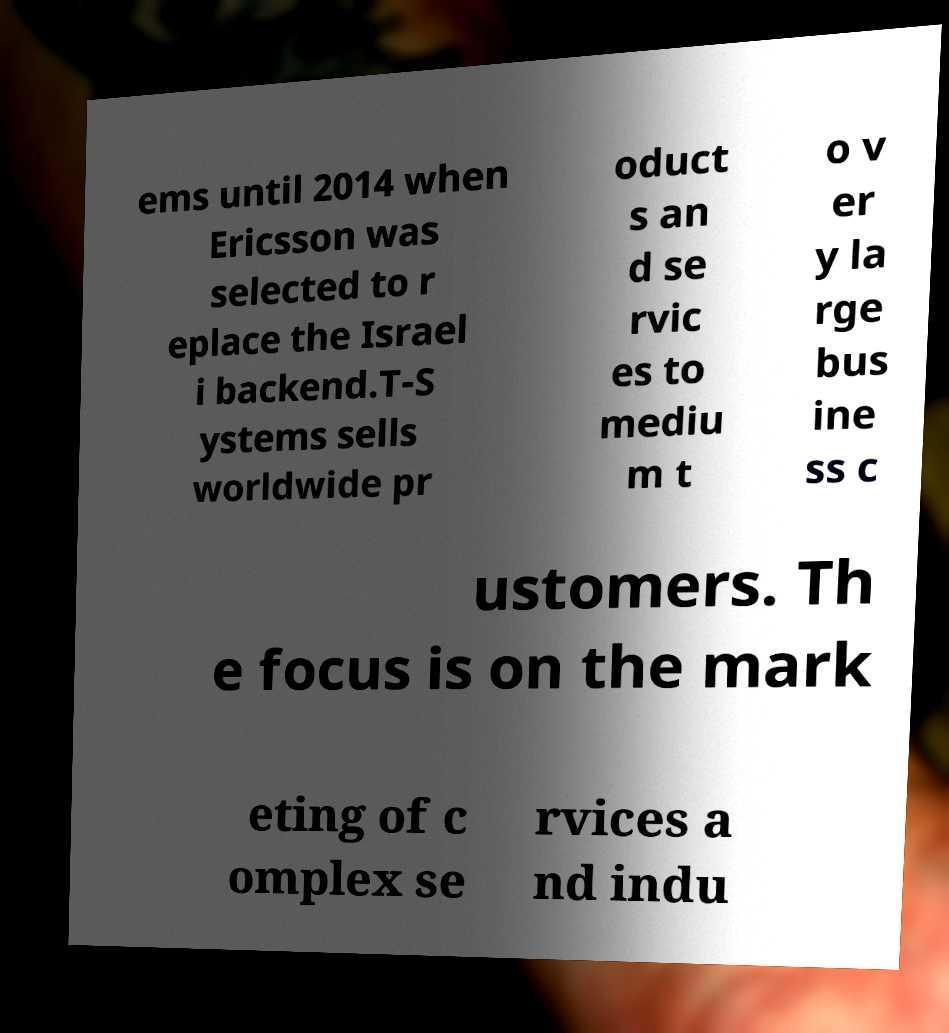Can you read and provide the text displayed in the image?This photo seems to have some interesting text. Can you extract and type it out for me? ems until 2014 when Ericsson was selected to r eplace the Israel i backend.T-S ystems sells worldwide pr oduct s an d se rvic es to mediu m t o v er y la rge bus ine ss c ustomers. Th e focus is on the mark eting of c omplex se rvices a nd indu 